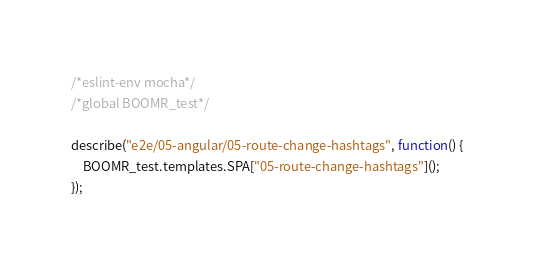<code> <loc_0><loc_0><loc_500><loc_500><_JavaScript_>/*eslint-env mocha*/
/*global BOOMR_test*/

describe("e2e/05-angular/05-route-change-hashtags", function() {
	BOOMR_test.templates.SPA["05-route-change-hashtags"]();
});
</code> 